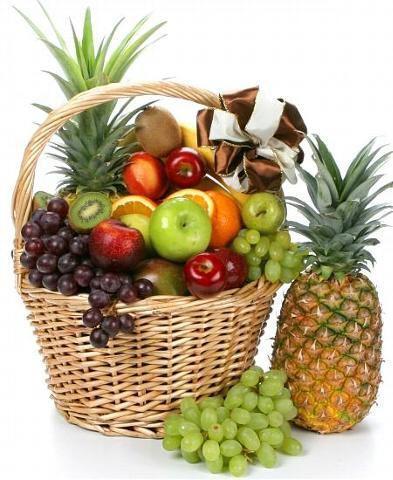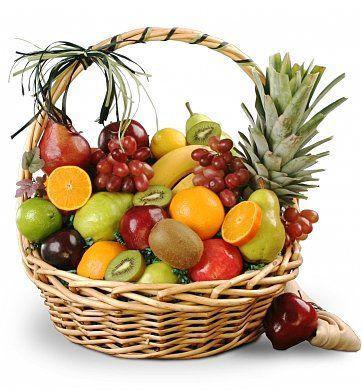The first image is the image on the left, the second image is the image on the right. Given the left and right images, does the statement "There are two wicker baskets." hold true? Answer yes or no. Yes. The first image is the image on the left, the second image is the image on the right. For the images displayed, is the sentence "Each image features a woven basket filled with a variety of at least three kinds of fruit, and at least one image features a basket with a round handle." factually correct? Answer yes or no. Yes. 